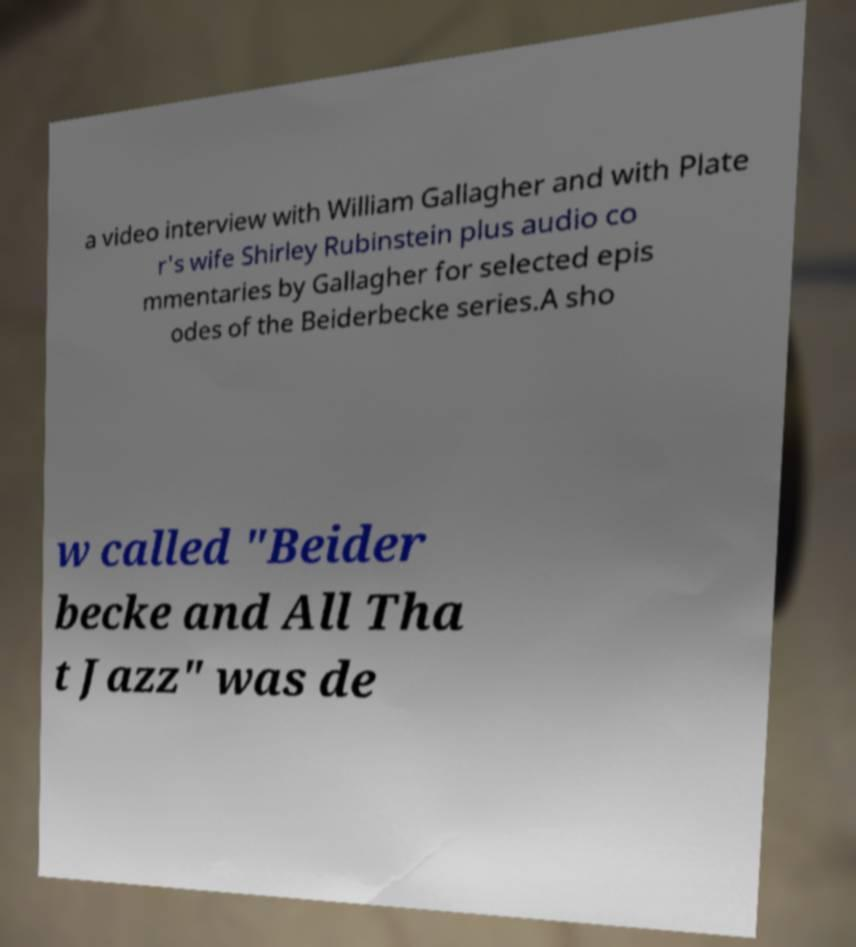What messages or text are displayed in this image? I need them in a readable, typed format. a video interview with William Gallagher and with Plate r's wife Shirley Rubinstein plus audio co mmentaries by Gallagher for selected epis odes of the Beiderbecke series.A sho w called "Beider becke and All Tha t Jazz" was de 